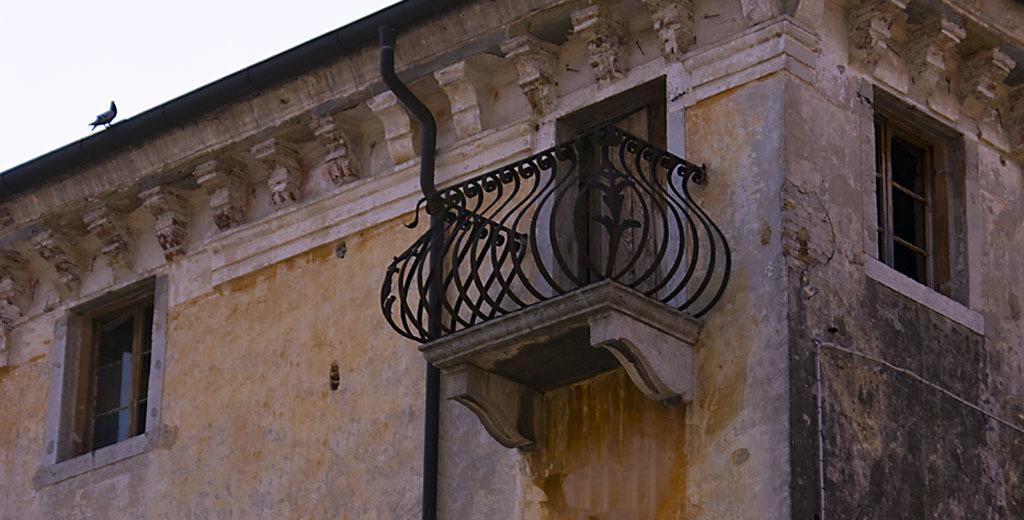Describe this image in one or two sentences. This image consists of a building along with windows and a door, near the door there is a railing. And there is a pigeon on the wall. 